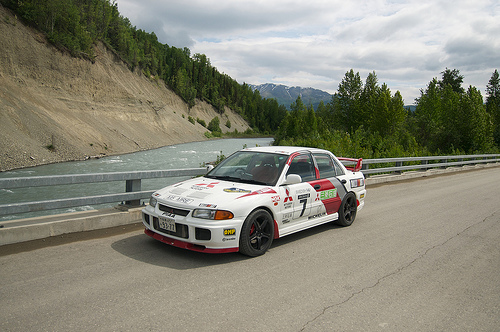<image>
Is the car on the water? No. The car is not positioned on the water. They may be near each other, but the car is not supported by or resting on top of the water. 